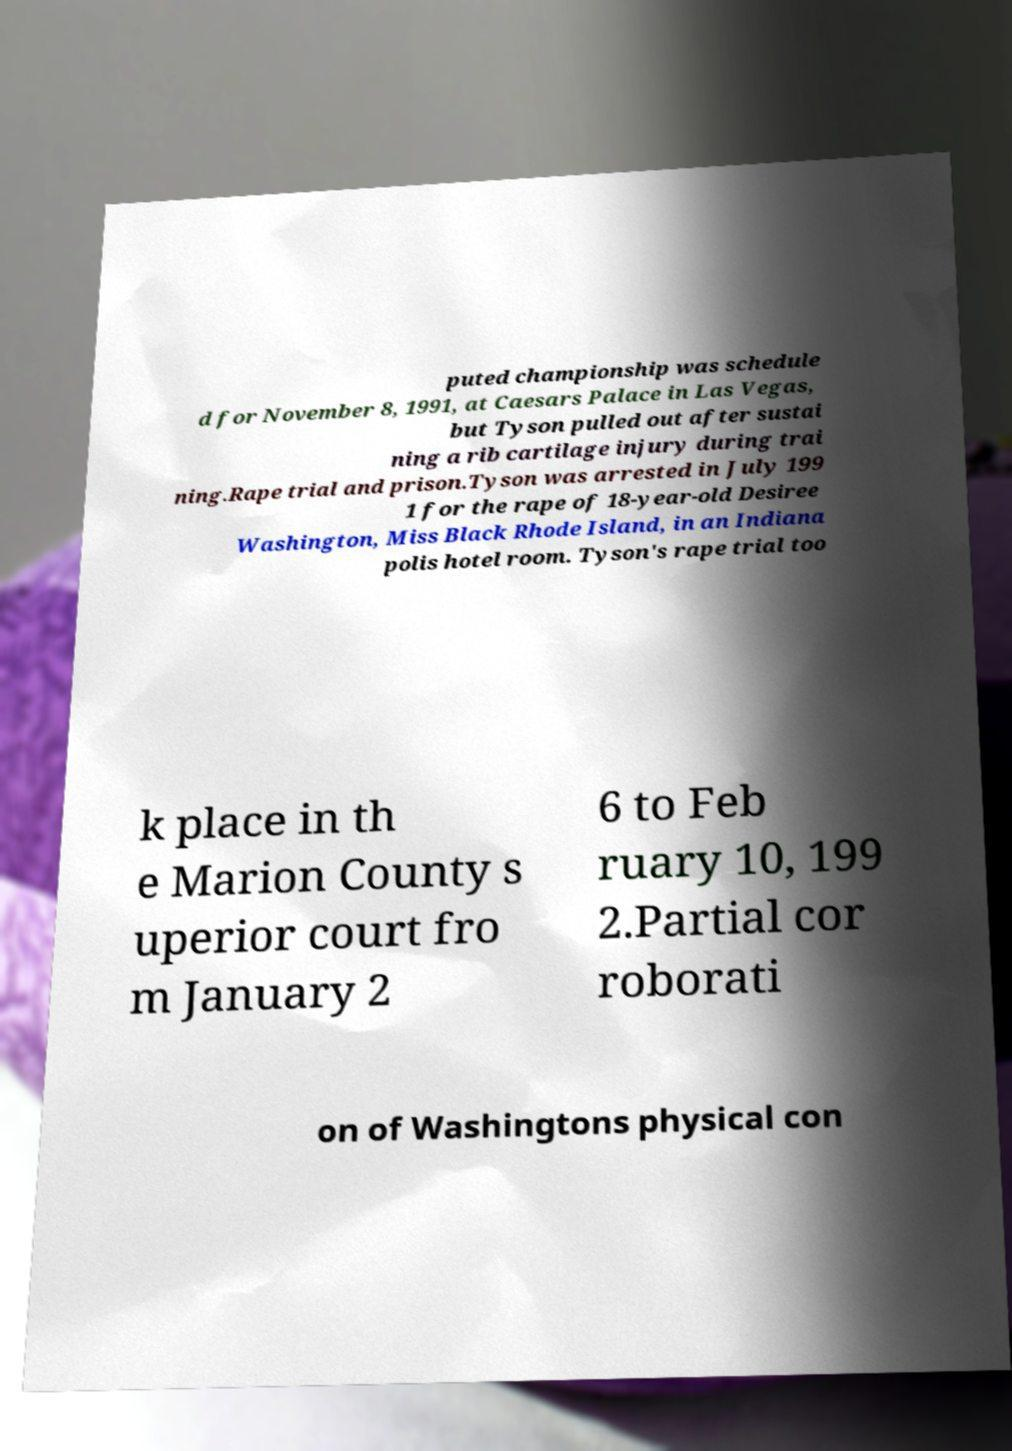There's text embedded in this image that I need extracted. Can you transcribe it verbatim? puted championship was schedule d for November 8, 1991, at Caesars Palace in Las Vegas, but Tyson pulled out after sustai ning a rib cartilage injury during trai ning.Rape trial and prison.Tyson was arrested in July 199 1 for the rape of 18-year-old Desiree Washington, Miss Black Rhode Island, in an Indiana polis hotel room. Tyson's rape trial too k place in th e Marion County s uperior court fro m January 2 6 to Feb ruary 10, 199 2.Partial cor roborati on of Washingtons physical con 